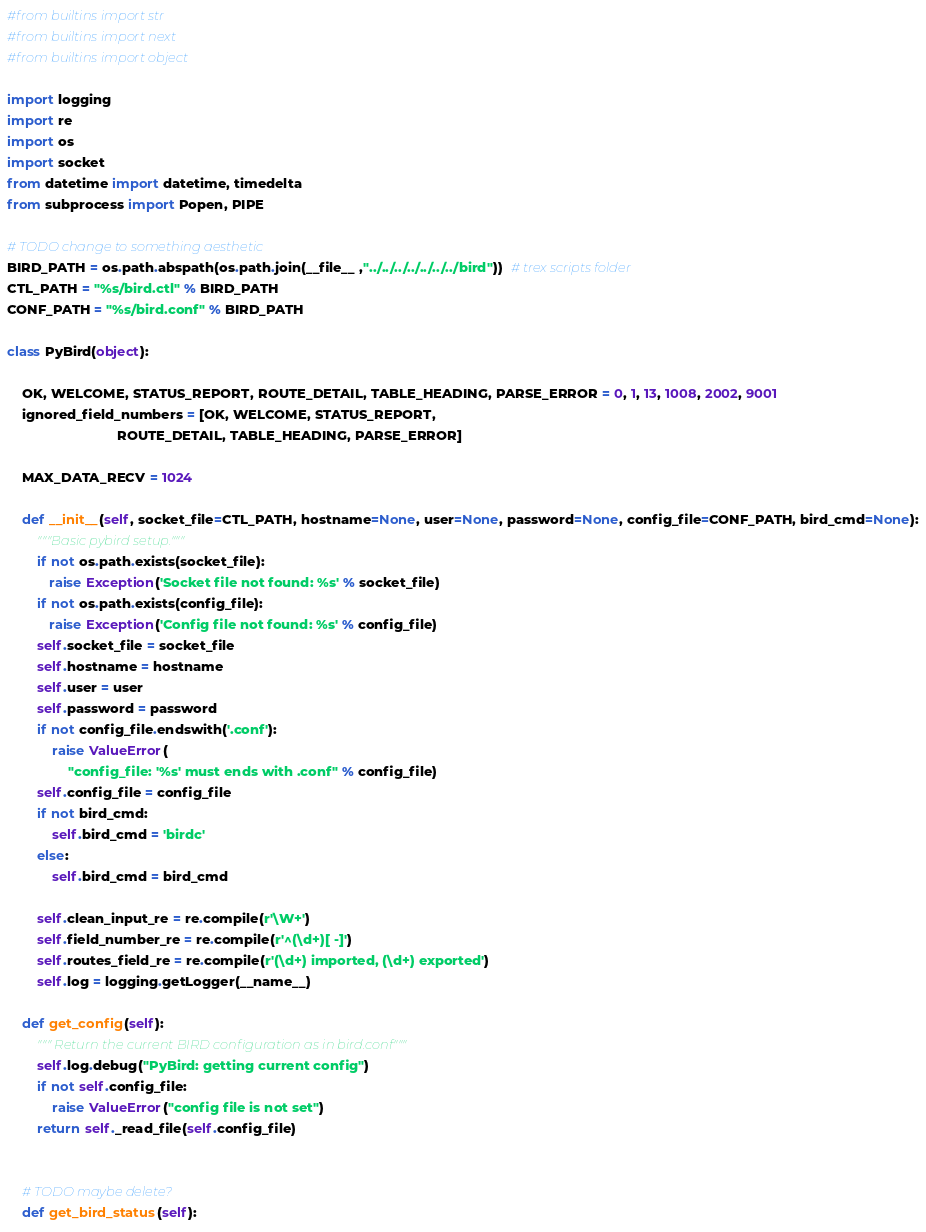Convert code to text. <code><loc_0><loc_0><loc_500><loc_500><_Python_>#from builtins import str
#from builtins import next
#from builtins import object

import logging
import re
import os
import socket
from datetime import datetime, timedelta
from subprocess import Popen, PIPE

# TODO change to something aesthetic 
BIRD_PATH = os.path.abspath(os.path.join(__file__ ,"../../../../../../../bird"))  # trex scripts folder 
CTL_PATH = "%s/bird.ctl" % BIRD_PATH
CONF_PATH = "%s/bird.conf" % BIRD_PATH 

class PyBird(object):

    OK, WELCOME, STATUS_REPORT, ROUTE_DETAIL, TABLE_HEADING, PARSE_ERROR = 0, 1, 13, 1008, 2002, 9001
    ignored_field_numbers = [OK, WELCOME, STATUS_REPORT,
                             ROUTE_DETAIL, TABLE_HEADING, PARSE_ERROR]

    MAX_DATA_RECV = 1024

    def __init__(self, socket_file=CTL_PATH, hostname=None, user=None, password=None, config_file=CONF_PATH, bird_cmd=None):
        """Basic pybird setup."""
        if not os.path.exists(socket_file):
           raise Exception('Socket file not found: %s' % socket_file)
        if not os.path.exists(config_file):
           raise Exception('Config file not found: %s' % config_file)
        self.socket_file = socket_file
        self.hostname = hostname
        self.user = user
        self.password = password
        if not config_file.endswith('.conf'):
            raise ValueError(
                "config_file: '%s' must ends with .conf" % config_file)
        self.config_file = config_file
        if not bird_cmd:
            self.bird_cmd = 'birdc'
        else:
            self.bird_cmd = bird_cmd

        self.clean_input_re = re.compile(r'\W+')
        self.field_number_re = re.compile(r'^(\d+)[ -]')
        self.routes_field_re = re.compile(r'(\d+) imported, (\d+) exported')
        self.log = logging.getLogger(__name__)

    def get_config(self):
        """ Return the current BIRD configuration as in bird.conf"""
        self.log.debug("PyBird: getting current config")
        if not self.config_file:
            raise ValueError("config file is not set")
        return self._read_file(self.config_file)


    # TODO maybe delete?
    def get_bird_status(self):</code> 